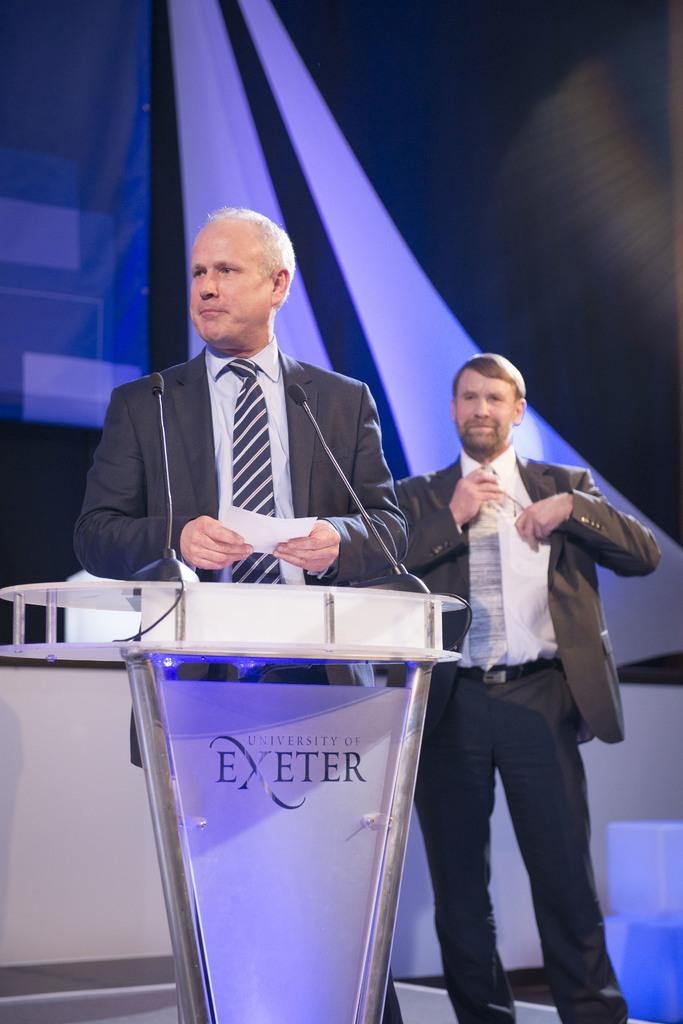<image>
Share a concise interpretation of the image provided. Two men standing behind a podium that says Exeter on it. 